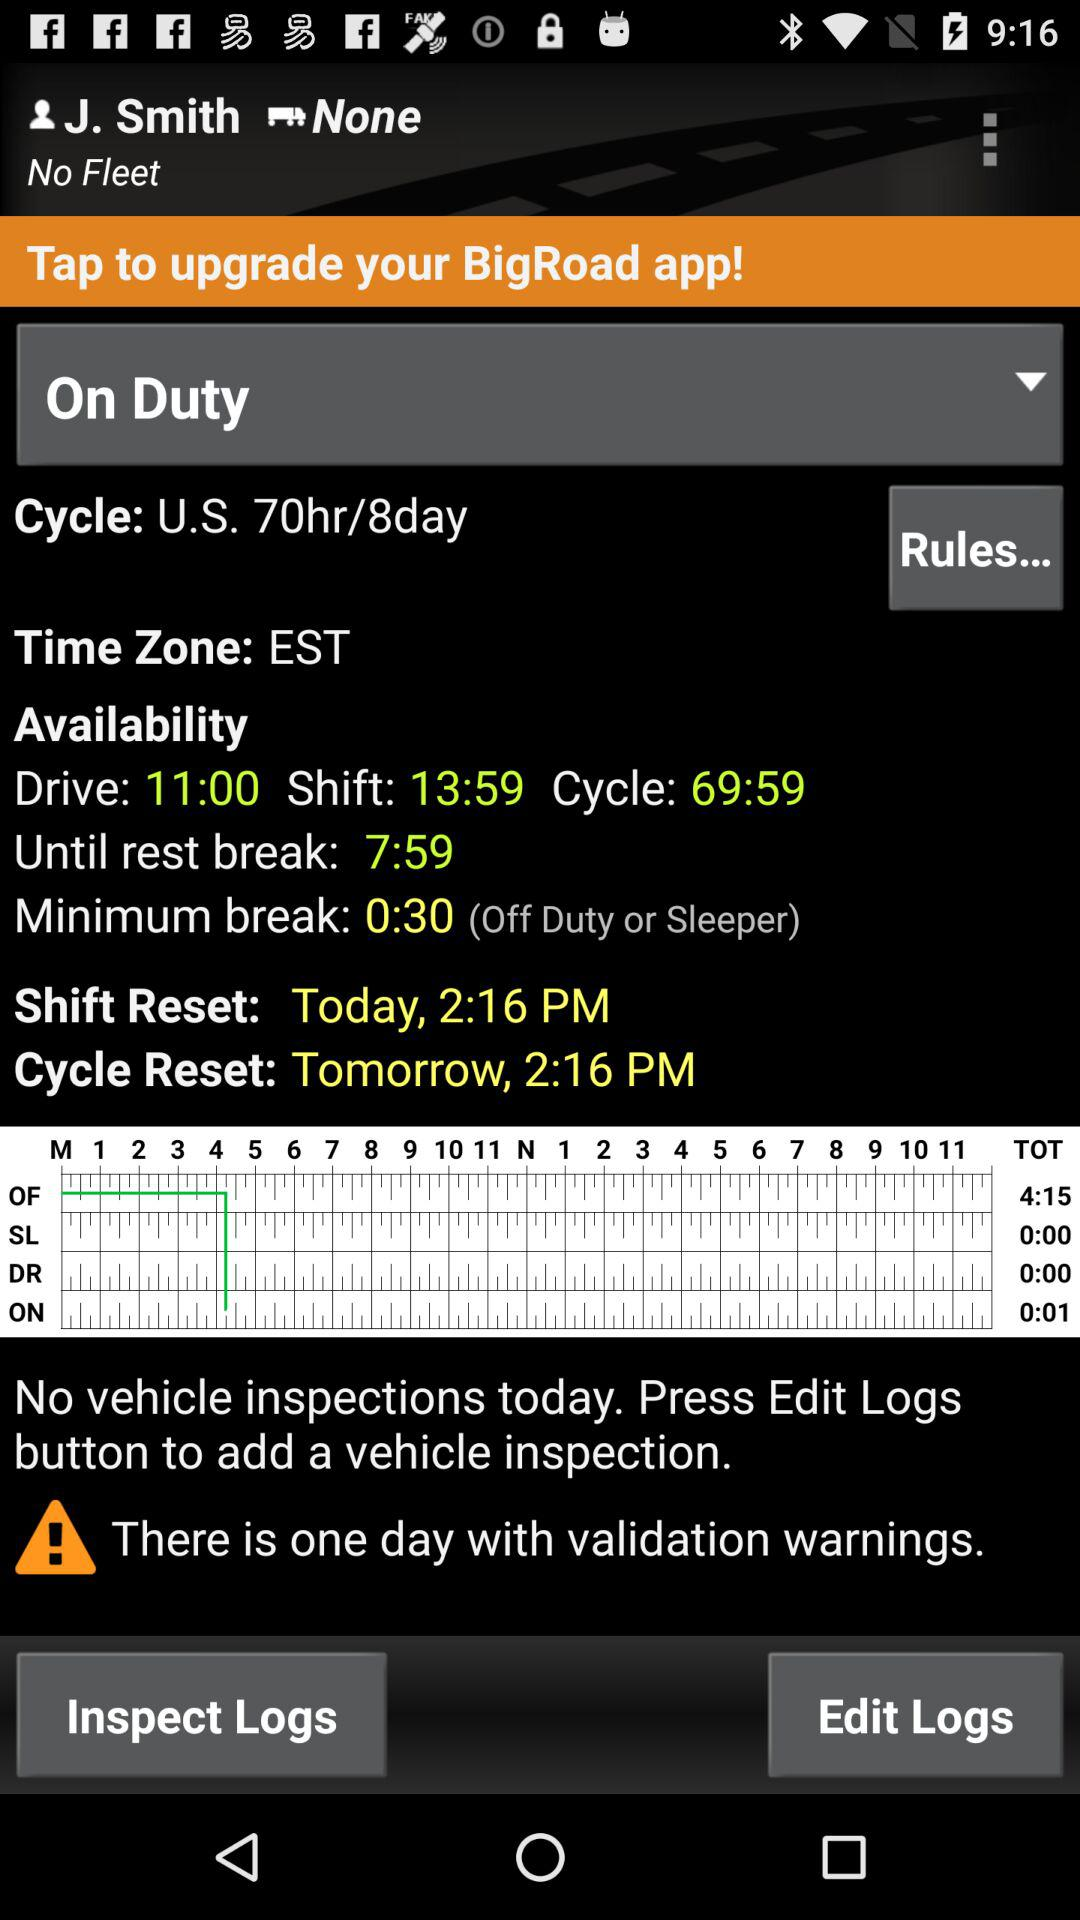What is the cycle reset timing? The cycle reset timing is 2:16 PM. 